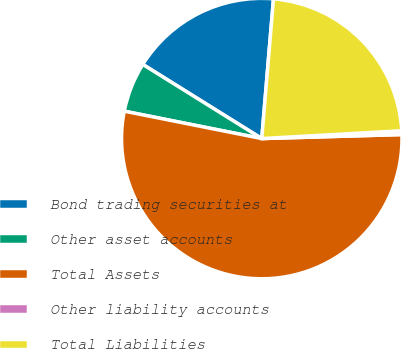Convert chart. <chart><loc_0><loc_0><loc_500><loc_500><pie_chart><fcel>Bond trading securities at<fcel>Other asset accounts<fcel>Total Assets<fcel>Other liability accounts<fcel>Total Liabilities<nl><fcel>17.46%<fcel>5.74%<fcel>53.58%<fcel>0.43%<fcel>22.78%<nl></chart> 